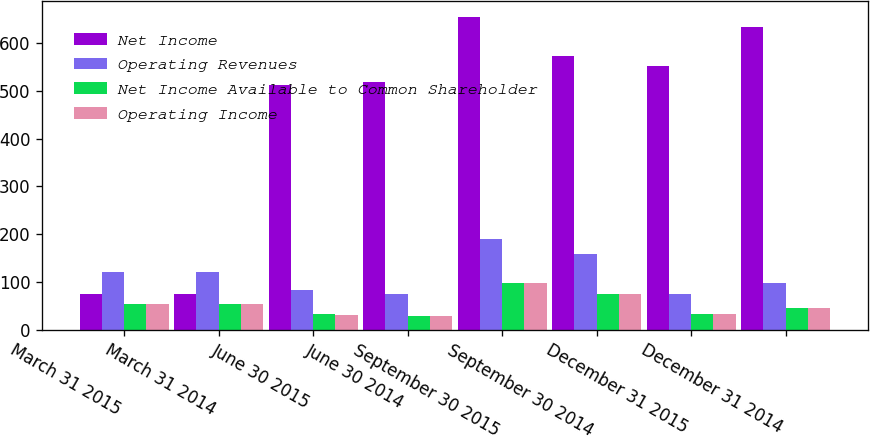Convert chart. <chart><loc_0><loc_0><loc_500><loc_500><stacked_bar_chart><ecel><fcel>March 31 2015<fcel>March 31 2014<fcel>June 30 2015<fcel>June 30 2014<fcel>September 30 2015<fcel>September 30 2014<fcel>December 31 2015<fcel>December 31 2014<nl><fcel>Net Income<fcel>75<fcel>75<fcel>513<fcel>519<fcel>655<fcel>572<fcel>553<fcel>633<nl><fcel>Operating Revenues<fcel>120<fcel>120<fcel>83<fcel>75<fcel>189<fcel>158<fcel>74<fcel>97<nl><fcel>Net Income Available to Common Shareholder<fcel>54<fcel>54<fcel>32<fcel>29<fcel>98<fcel>75<fcel>33<fcel>46<nl><fcel>Operating Income<fcel>53<fcel>53<fcel>31<fcel>28<fcel>98<fcel>75<fcel>32<fcel>45<nl></chart> 